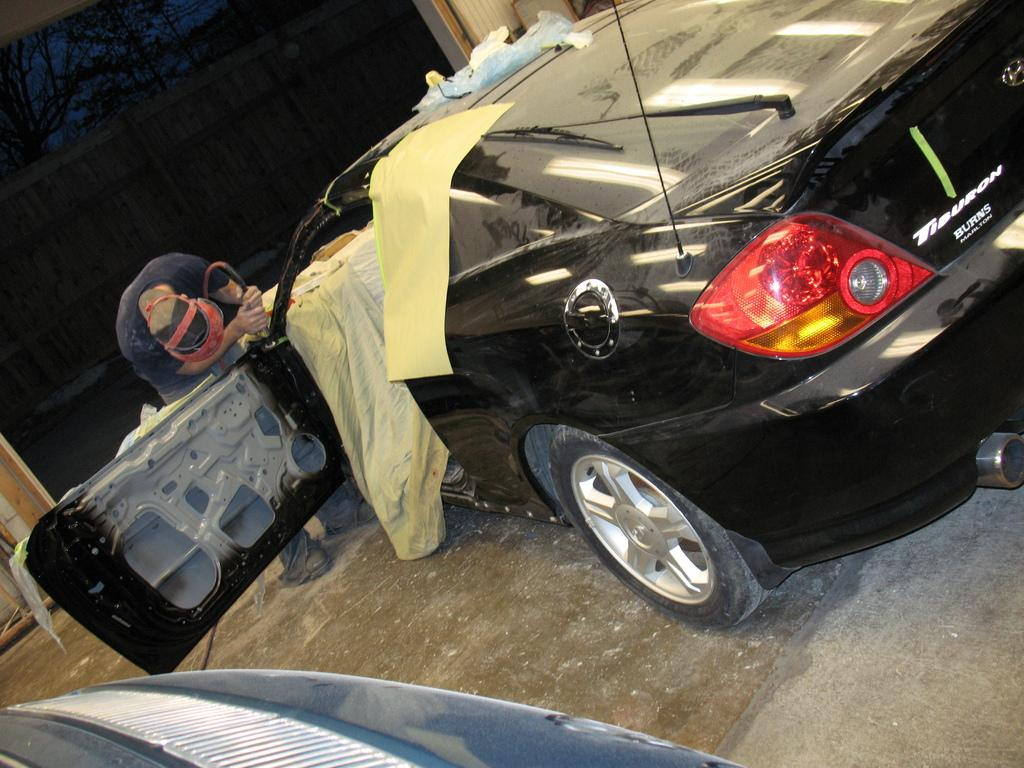What is the main subject of the image? There is a car in the image. What other objects can be seen in the image? There is cloth, paper, and a mascot in the image. What is the color of the background in the image? The background of the image is dark. What type of clam is being used as a reaction to the mascot in the image? There is no clam present in the image, and therefore no reaction involving a clam can be observed. 